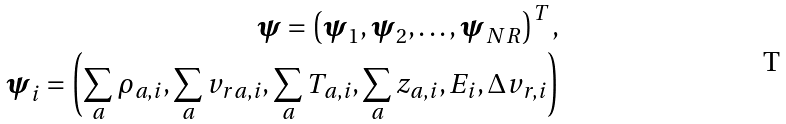<formula> <loc_0><loc_0><loc_500><loc_500>\boldsymbol \psi = \left ( { \boldsymbol \psi _ { 1 } , \boldsymbol \psi _ { 2 } , \dots , \boldsymbol \psi _ { N \, R } } \right ) ^ { T } , \\ \boldsymbol \psi _ { i } = \left ( { \sum _ { a } \rho _ { a , i } , \sum _ { a } v _ { r a , i } , \sum _ { a } T _ { a , i } , \sum _ { a } z _ { a , i } , E _ { i } , \Delta v _ { r , i } } \right )</formula> 